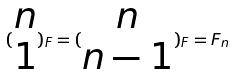Convert formula to latex. <formula><loc_0><loc_0><loc_500><loc_500>( \begin{matrix} n \\ 1 \end{matrix} ) _ { F } = ( \begin{matrix} n \\ n - 1 \end{matrix} ) _ { F } = F _ { n }</formula> 